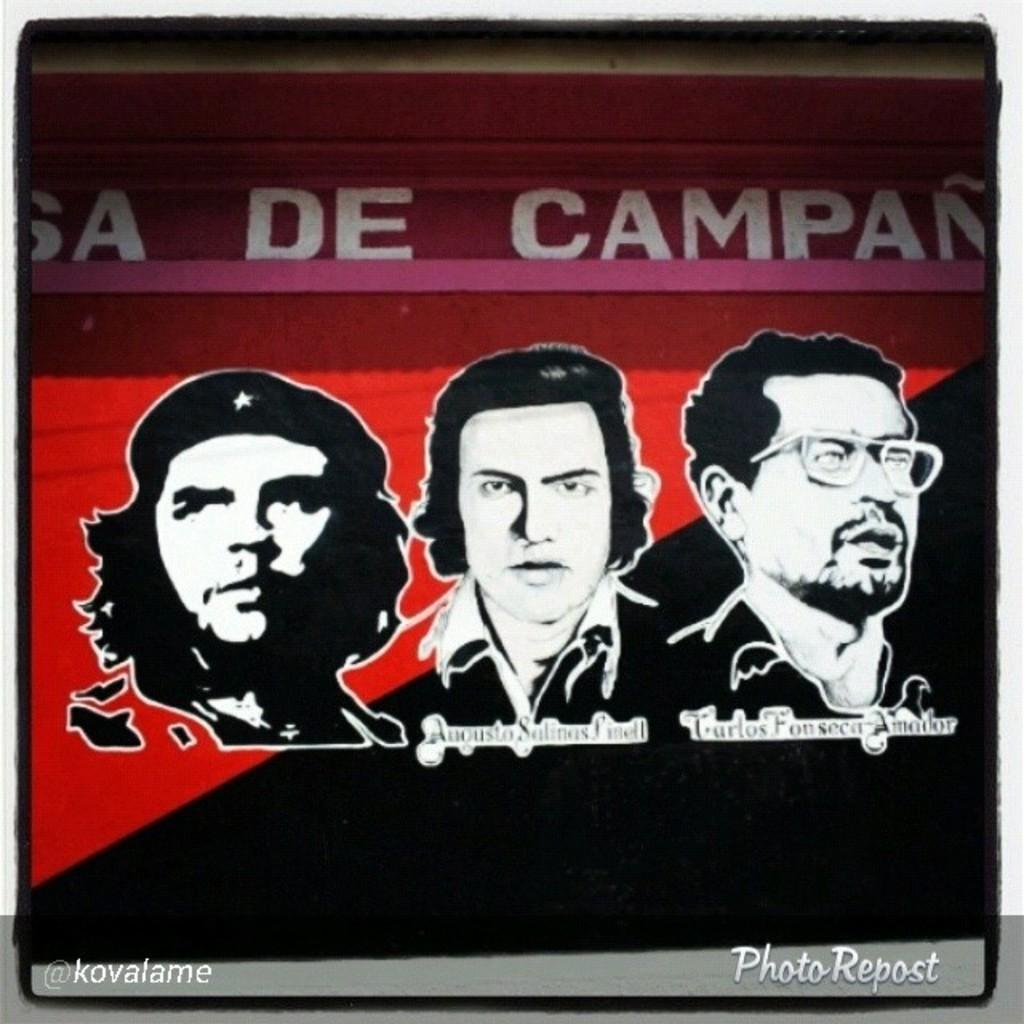What is featured in the image? There is a poster in the image. What colors are used on the poster? The poster has black and red colors. Who or what is depicted on the poster? There are three men depicted on the poster. Are there any words or names on the poster? Yes, there are names on the poster. What type of teeth can be seen on the poster? There are no teeth depicted on the poster; it features three men. Is the poster made of wax? There is no information about the material of the poster, but it is not mentioned to be made of wax. 